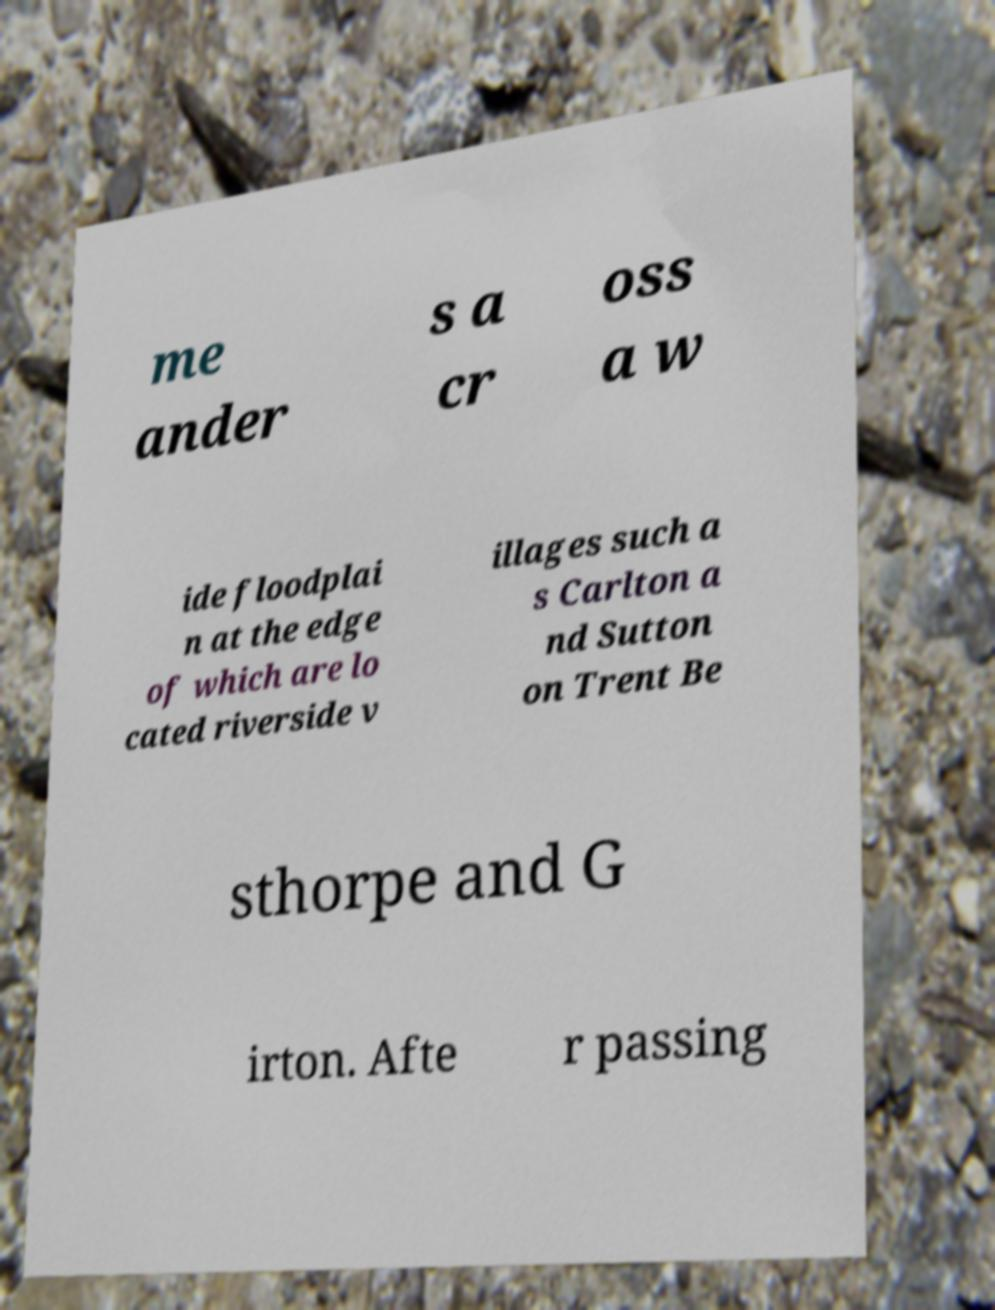Can you read and provide the text displayed in the image?This photo seems to have some interesting text. Can you extract and type it out for me? me ander s a cr oss a w ide floodplai n at the edge of which are lo cated riverside v illages such a s Carlton a nd Sutton on Trent Be sthorpe and G irton. Afte r passing 